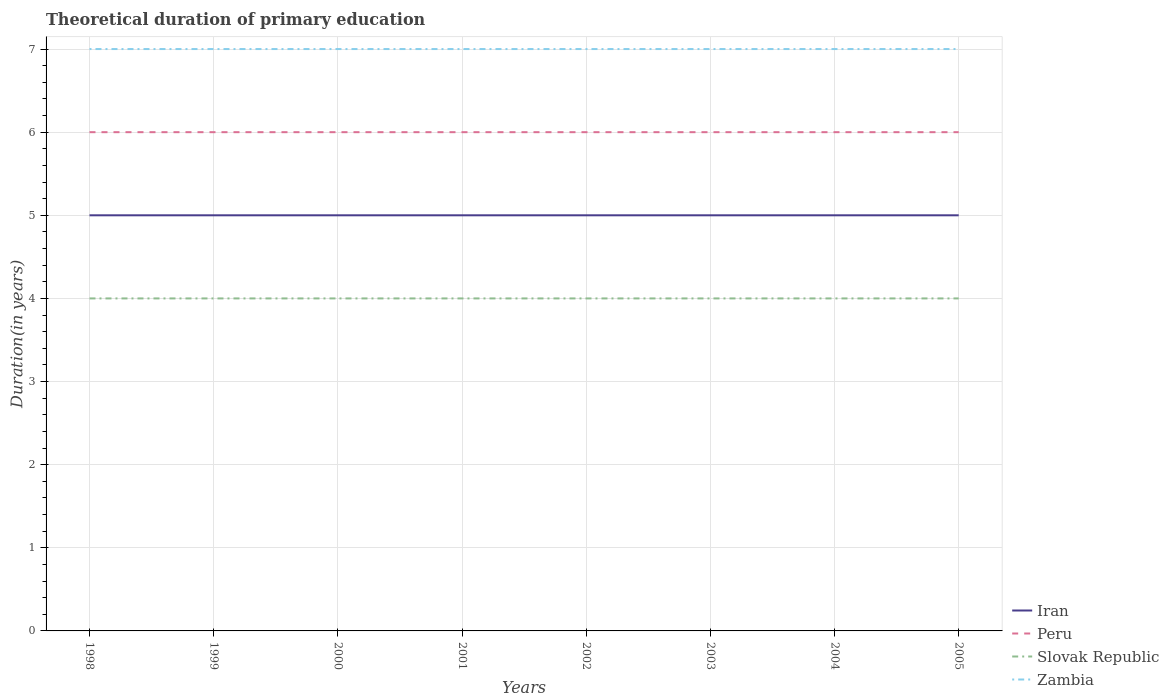Is the number of lines equal to the number of legend labels?
Give a very brief answer. Yes. Across all years, what is the maximum total theoretical duration of primary education in Zambia?
Your answer should be compact. 7. Is the total theoretical duration of primary education in Iran strictly greater than the total theoretical duration of primary education in Peru over the years?
Offer a very short reply. Yes. How many lines are there?
Provide a succinct answer. 4. How many years are there in the graph?
Keep it short and to the point. 8. Does the graph contain grids?
Make the answer very short. Yes. Where does the legend appear in the graph?
Your response must be concise. Bottom right. How many legend labels are there?
Keep it short and to the point. 4. How are the legend labels stacked?
Offer a terse response. Vertical. What is the title of the graph?
Give a very brief answer. Theoretical duration of primary education. What is the label or title of the Y-axis?
Keep it short and to the point. Duration(in years). What is the Duration(in years) of Peru in 1998?
Your answer should be very brief. 6. What is the Duration(in years) in Zambia in 1998?
Offer a very short reply. 7. What is the Duration(in years) in Peru in 1999?
Give a very brief answer. 6. What is the Duration(in years) of Iran in 2000?
Keep it short and to the point. 5. What is the Duration(in years) in Slovak Republic in 2001?
Your answer should be very brief. 4. What is the Duration(in years) in Iran in 2002?
Provide a short and direct response. 5. What is the Duration(in years) of Iran in 2003?
Offer a terse response. 5. What is the Duration(in years) of Peru in 2003?
Give a very brief answer. 6. What is the Duration(in years) of Zambia in 2003?
Make the answer very short. 7. What is the Duration(in years) of Iran in 2004?
Your answer should be compact. 5. What is the Duration(in years) in Iran in 2005?
Offer a very short reply. 5. Across all years, what is the maximum Duration(in years) of Iran?
Ensure brevity in your answer.  5. Across all years, what is the maximum Duration(in years) of Peru?
Ensure brevity in your answer.  6. Across all years, what is the maximum Duration(in years) in Slovak Republic?
Offer a terse response. 4. Across all years, what is the minimum Duration(in years) in Iran?
Your response must be concise. 5. Across all years, what is the minimum Duration(in years) of Peru?
Your answer should be very brief. 6. Across all years, what is the minimum Duration(in years) of Slovak Republic?
Your answer should be compact. 4. Across all years, what is the minimum Duration(in years) of Zambia?
Ensure brevity in your answer.  7. What is the total Duration(in years) in Iran in the graph?
Make the answer very short. 40. What is the total Duration(in years) of Peru in the graph?
Make the answer very short. 48. What is the difference between the Duration(in years) in Peru in 1998 and that in 1999?
Offer a very short reply. 0. What is the difference between the Duration(in years) of Iran in 1998 and that in 2000?
Offer a very short reply. 0. What is the difference between the Duration(in years) of Slovak Republic in 1998 and that in 2000?
Your answer should be compact. 0. What is the difference between the Duration(in years) in Zambia in 1998 and that in 2000?
Keep it short and to the point. 0. What is the difference between the Duration(in years) of Peru in 1998 and that in 2001?
Ensure brevity in your answer.  0. What is the difference between the Duration(in years) in Slovak Republic in 1998 and that in 2001?
Provide a short and direct response. 0. What is the difference between the Duration(in years) of Slovak Republic in 1998 and that in 2002?
Give a very brief answer. 0. What is the difference between the Duration(in years) of Iran in 1998 and that in 2003?
Make the answer very short. 0. What is the difference between the Duration(in years) in Iran in 1998 and that in 2004?
Your answer should be very brief. 0. What is the difference between the Duration(in years) of Iran in 1998 and that in 2005?
Ensure brevity in your answer.  0. What is the difference between the Duration(in years) of Peru in 1999 and that in 2000?
Keep it short and to the point. 0. What is the difference between the Duration(in years) of Zambia in 1999 and that in 2000?
Your answer should be very brief. 0. What is the difference between the Duration(in years) in Iran in 1999 and that in 2001?
Keep it short and to the point. 0. What is the difference between the Duration(in years) of Zambia in 1999 and that in 2001?
Your response must be concise. 0. What is the difference between the Duration(in years) of Iran in 1999 and that in 2002?
Provide a short and direct response. 0. What is the difference between the Duration(in years) in Slovak Republic in 1999 and that in 2002?
Your response must be concise. 0. What is the difference between the Duration(in years) of Zambia in 1999 and that in 2002?
Ensure brevity in your answer.  0. What is the difference between the Duration(in years) in Iran in 1999 and that in 2003?
Make the answer very short. 0. What is the difference between the Duration(in years) of Slovak Republic in 1999 and that in 2003?
Provide a succinct answer. 0. What is the difference between the Duration(in years) in Zambia in 1999 and that in 2004?
Provide a succinct answer. 0. What is the difference between the Duration(in years) of Iran in 1999 and that in 2005?
Offer a very short reply. 0. What is the difference between the Duration(in years) of Zambia in 1999 and that in 2005?
Provide a succinct answer. 0. What is the difference between the Duration(in years) of Iran in 2000 and that in 2001?
Offer a terse response. 0. What is the difference between the Duration(in years) in Slovak Republic in 2000 and that in 2001?
Keep it short and to the point. 0. What is the difference between the Duration(in years) in Zambia in 2000 and that in 2001?
Make the answer very short. 0. What is the difference between the Duration(in years) of Iran in 2000 and that in 2002?
Give a very brief answer. 0. What is the difference between the Duration(in years) of Peru in 2000 and that in 2002?
Your answer should be very brief. 0. What is the difference between the Duration(in years) in Slovak Republic in 2000 and that in 2002?
Offer a terse response. 0. What is the difference between the Duration(in years) of Zambia in 2000 and that in 2002?
Keep it short and to the point. 0. What is the difference between the Duration(in years) in Iran in 2000 and that in 2003?
Provide a short and direct response. 0. What is the difference between the Duration(in years) of Slovak Republic in 2000 and that in 2003?
Offer a very short reply. 0. What is the difference between the Duration(in years) in Zambia in 2000 and that in 2003?
Provide a succinct answer. 0. What is the difference between the Duration(in years) of Iran in 2000 and that in 2004?
Ensure brevity in your answer.  0. What is the difference between the Duration(in years) of Peru in 2000 and that in 2004?
Your answer should be compact. 0. What is the difference between the Duration(in years) in Iran in 2000 and that in 2005?
Provide a succinct answer. 0. What is the difference between the Duration(in years) of Peru in 2000 and that in 2005?
Keep it short and to the point. 0. What is the difference between the Duration(in years) in Iran in 2001 and that in 2002?
Ensure brevity in your answer.  0. What is the difference between the Duration(in years) of Slovak Republic in 2001 and that in 2002?
Offer a terse response. 0. What is the difference between the Duration(in years) of Zambia in 2001 and that in 2002?
Provide a short and direct response. 0. What is the difference between the Duration(in years) of Slovak Republic in 2001 and that in 2003?
Offer a terse response. 0. What is the difference between the Duration(in years) of Peru in 2001 and that in 2004?
Keep it short and to the point. 0. What is the difference between the Duration(in years) in Slovak Republic in 2001 and that in 2004?
Your answer should be very brief. 0. What is the difference between the Duration(in years) of Zambia in 2001 and that in 2004?
Offer a terse response. 0. What is the difference between the Duration(in years) in Iran in 2001 and that in 2005?
Ensure brevity in your answer.  0. What is the difference between the Duration(in years) in Zambia in 2001 and that in 2005?
Offer a terse response. 0. What is the difference between the Duration(in years) of Peru in 2002 and that in 2003?
Your response must be concise. 0. What is the difference between the Duration(in years) in Slovak Republic in 2002 and that in 2003?
Make the answer very short. 0. What is the difference between the Duration(in years) in Iran in 2002 and that in 2004?
Make the answer very short. 0. What is the difference between the Duration(in years) of Slovak Republic in 2002 and that in 2004?
Make the answer very short. 0. What is the difference between the Duration(in years) of Zambia in 2002 and that in 2004?
Provide a short and direct response. 0. What is the difference between the Duration(in years) of Iran in 2002 and that in 2005?
Ensure brevity in your answer.  0. What is the difference between the Duration(in years) in Peru in 2002 and that in 2005?
Make the answer very short. 0. What is the difference between the Duration(in years) of Iran in 2003 and that in 2004?
Keep it short and to the point. 0. What is the difference between the Duration(in years) in Peru in 2003 and that in 2004?
Your answer should be very brief. 0. What is the difference between the Duration(in years) in Slovak Republic in 2003 and that in 2004?
Provide a short and direct response. 0. What is the difference between the Duration(in years) in Iran in 2003 and that in 2005?
Give a very brief answer. 0. What is the difference between the Duration(in years) of Peru in 2003 and that in 2005?
Ensure brevity in your answer.  0. What is the difference between the Duration(in years) in Slovak Republic in 2003 and that in 2005?
Your answer should be very brief. 0. What is the difference between the Duration(in years) of Iran in 2004 and that in 2005?
Your response must be concise. 0. What is the difference between the Duration(in years) in Peru in 2004 and that in 2005?
Offer a terse response. 0. What is the difference between the Duration(in years) in Slovak Republic in 2004 and that in 2005?
Keep it short and to the point. 0. What is the difference between the Duration(in years) of Zambia in 2004 and that in 2005?
Your answer should be compact. 0. What is the difference between the Duration(in years) in Iran in 1998 and the Duration(in years) in Slovak Republic in 1999?
Your response must be concise. 1. What is the difference between the Duration(in years) of Iran in 1998 and the Duration(in years) of Zambia in 1999?
Give a very brief answer. -2. What is the difference between the Duration(in years) of Peru in 1998 and the Duration(in years) of Slovak Republic in 1999?
Give a very brief answer. 2. What is the difference between the Duration(in years) in Peru in 1998 and the Duration(in years) in Zambia in 1999?
Offer a terse response. -1. What is the difference between the Duration(in years) in Iran in 1998 and the Duration(in years) in Peru in 2000?
Provide a short and direct response. -1. What is the difference between the Duration(in years) of Iran in 1998 and the Duration(in years) of Slovak Republic in 2000?
Provide a succinct answer. 1. What is the difference between the Duration(in years) of Iran in 1998 and the Duration(in years) of Zambia in 2000?
Your answer should be compact. -2. What is the difference between the Duration(in years) in Peru in 1998 and the Duration(in years) in Slovak Republic in 2000?
Provide a short and direct response. 2. What is the difference between the Duration(in years) of Peru in 1998 and the Duration(in years) of Zambia in 2000?
Offer a very short reply. -1. What is the difference between the Duration(in years) in Iran in 1998 and the Duration(in years) in Peru in 2001?
Your answer should be compact. -1. What is the difference between the Duration(in years) in Iran in 1998 and the Duration(in years) in Zambia in 2001?
Provide a succinct answer. -2. What is the difference between the Duration(in years) of Peru in 1998 and the Duration(in years) of Slovak Republic in 2001?
Offer a very short reply. 2. What is the difference between the Duration(in years) in Slovak Republic in 1998 and the Duration(in years) in Zambia in 2001?
Provide a succinct answer. -3. What is the difference between the Duration(in years) of Iran in 1998 and the Duration(in years) of Slovak Republic in 2002?
Offer a very short reply. 1. What is the difference between the Duration(in years) in Iran in 1998 and the Duration(in years) in Zambia in 2002?
Your response must be concise. -2. What is the difference between the Duration(in years) of Peru in 1998 and the Duration(in years) of Slovak Republic in 2002?
Provide a succinct answer. 2. What is the difference between the Duration(in years) in Peru in 1998 and the Duration(in years) in Zambia in 2002?
Offer a terse response. -1. What is the difference between the Duration(in years) in Iran in 1998 and the Duration(in years) in Peru in 2003?
Provide a short and direct response. -1. What is the difference between the Duration(in years) of Iran in 1998 and the Duration(in years) of Slovak Republic in 2003?
Make the answer very short. 1. What is the difference between the Duration(in years) of Peru in 1998 and the Duration(in years) of Zambia in 2003?
Offer a very short reply. -1. What is the difference between the Duration(in years) in Slovak Republic in 1998 and the Duration(in years) in Zambia in 2003?
Give a very brief answer. -3. What is the difference between the Duration(in years) in Iran in 1998 and the Duration(in years) in Zambia in 2004?
Give a very brief answer. -2. What is the difference between the Duration(in years) in Peru in 1998 and the Duration(in years) in Slovak Republic in 2004?
Your answer should be compact. 2. What is the difference between the Duration(in years) of Peru in 1998 and the Duration(in years) of Zambia in 2004?
Ensure brevity in your answer.  -1. What is the difference between the Duration(in years) of Iran in 1998 and the Duration(in years) of Slovak Republic in 2005?
Your answer should be compact. 1. What is the difference between the Duration(in years) in Iran in 1998 and the Duration(in years) in Zambia in 2005?
Provide a short and direct response. -2. What is the difference between the Duration(in years) of Peru in 1998 and the Duration(in years) of Zambia in 2005?
Make the answer very short. -1. What is the difference between the Duration(in years) in Slovak Republic in 1998 and the Duration(in years) in Zambia in 2005?
Your response must be concise. -3. What is the difference between the Duration(in years) of Iran in 1999 and the Duration(in years) of Peru in 2000?
Your answer should be compact. -1. What is the difference between the Duration(in years) in Peru in 1999 and the Duration(in years) in Slovak Republic in 2000?
Ensure brevity in your answer.  2. What is the difference between the Duration(in years) in Peru in 1999 and the Duration(in years) in Zambia in 2000?
Offer a terse response. -1. What is the difference between the Duration(in years) in Iran in 1999 and the Duration(in years) in Peru in 2001?
Make the answer very short. -1. What is the difference between the Duration(in years) of Peru in 1999 and the Duration(in years) of Slovak Republic in 2001?
Your answer should be compact. 2. What is the difference between the Duration(in years) in Peru in 1999 and the Duration(in years) in Zambia in 2001?
Offer a terse response. -1. What is the difference between the Duration(in years) in Slovak Republic in 1999 and the Duration(in years) in Zambia in 2001?
Your response must be concise. -3. What is the difference between the Duration(in years) in Peru in 1999 and the Duration(in years) in Slovak Republic in 2002?
Give a very brief answer. 2. What is the difference between the Duration(in years) in Peru in 1999 and the Duration(in years) in Zambia in 2002?
Your answer should be very brief. -1. What is the difference between the Duration(in years) in Slovak Republic in 1999 and the Duration(in years) in Zambia in 2002?
Offer a very short reply. -3. What is the difference between the Duration(in years) in Iran in 1999 and the Duration(in years) in Peru in 2003?
Your answer should be compact. -1. What is the difference between the Duration(in years) of Iran in 1999 and the Duration(in years) of Slovak Republic in 2003?
Ensure brevity in your answer.  1. What is the difference between the Duration(in years) of Iran in 1999 and the Duration(in years) of Zambia in 2003?
Offer a very short reply. -2. What is the difference between the Duration(in years) of Iran in 1999 and the Duration(in years) of Slovak Republic in 2004?
Give a very brief answer. 1. What is the difference between the Duration(in years) in Iran in 1999 and the Duration(in years) in Slovak Republic in 2005?
Offer a terse response. 1. What is the difference between the Duration(in years) in Iran in 1999 and the Duration(in years) in Zambia in 2005?
Give a very brief answer. -2. What is the difference between the Duration(in years) of Peru in 1999 and the Duration(in years) of Slovak Republic in 2005?
Provide a succinct answer. 2. What is the difference between the Duration(in years) of Iran in 2000 and the Duration(in years) of Zambia in 2001?
Your answer should be compact. -2. What is the difference between the Duration(in years) in Iran in 2000 and the Duration(in years) in Peru in 2003?
Offer a very short reply. -1. What is the difference between the Duration(in years) in Iran in 2000 and the Duration(in years) in Slovak Republic in 2003?
Ensure brevity in your answer.  1. What is the difference between the Duration(in years) of Iran in 2000 and the Duration(in years) of Zambia in 2003?
Make the answer very short. -2. What is the difference between the Duration(in years) in Slovak Republic in 2000 and the Duration(in years) in Zambia in 2003?
Provide a succinct answer. -3. What is the difference between the Duration(in years) in Iran in 2000 and the Duration(in years) in Peru in 2004?
Your response must be concise. -1. What is the difference between the Duration(in years) in Peru in 2000 and the Duration(in years) in Zambia in 2004?
Provide a short and direct response. -1. What is the difference between the Duration(in years) in Iran in 2000 and the Duration(in years) in Peru in 2005?
Provide a succinct answer. -1. What is the difference between the Duration(in years) in Iran in 2000 and the Duration(in years) in Slovak Republic in 2005?
Offer a very short reply. 1. What is the difference between the Duration(in years) of Iran in 2000 and the Duration(in years) of Zambia in 2005?
Offer a very short reply. -2. What is the difference between the Duration(in years) in Peru in 2000 and the Duration(in years) in Slovak Republic in 2005?
Make the answer very short. 2. What is the difference between the Duration(in years) in Slovak Republic in 2000 and the Duration(in years) in Zambia in 2005?
Your answer should be compact. -3. What is the difference between the Duration(in years) in Iran in 2001 and the Duration(in years) in Slovak Republic in 2002?
Your answer should be very brief. 1. What is the difference between the Duration(in years) in Peru in 2001 and the Duration(in years) in Zambia in 2002?
Offer a very short reply. -1. What is the difference between the Duration(in years) in Iran in 2001 and the Duration(in years) in Slovak Republic in 2003?
Give a very brief answer. 1. What is the difference between the Duration(in years) of Iran in 2001 and the Duration(in years) of Peru in 2004?
Ensure brevity in your answer.  -1. What is the difference between the Duration(in years) in Iran in 2001 and the Duration(in years) in Zambia in 2004?
Keep it short and to the point. -2. What is the difference between the Duration(in years) in Slovak Republic in 2001 and the Duration(in years) in Zambia in 2004?
Offer a very short reply. -3. What is the difference between the Duration(in years) in Slovak Republic in 2001 and the Duration(in years) in Zambia in 2005?
Ensure brevity in your answer.  -3. What is the difference between the Duration(in years) of Iran in 2002 and the Duration(in years) of Peru in 2003?
Give a very brief answer. -1. What is the difference between the Duration(in years) in Iran in 2002 and the Duration(in years) in Zambia in 2003?
Give a very brief answer. -2. What is the difference between the Duration(in years) of Peru in 2002 and the Duration(in years) of Slovak Republic in 2003?
Provide a short and direct response. 2. What is the difference between the Duration(in years) of Peru in 2002 and the Duration(in years) of Zambia in 2003?
Provide a short and direct response. -1. What is the difference between the Duration(in years) in Iran in 2002 and the Duration(in years) in Slovak Republic in 2004?
Provide a short and direct response. 1. What is the difference between the Duration(in years) in Iran in 2002 and the Duration(in years) in Peru in 2005?
Your response must be concise. -1. What is the difference between the Duration(in years) in Iran in 2002 and the Duration(in years) in Zambia in 2005?
Keep it short and to the point. -2. What is the difference between the Duration(in years) of Peru in 2002 and the Duration(in years) of Slovak Republic in 2005?
Keep it short and to the point. 2. What is the difference between the Duration(in years) of Iran in 2003 and the Duration(in years) of Zambia in 2004?
Make the answer very short. -2. What is the difference between the Duration(in years) in Slovak Republic in 2003 and the Duration(in years) in Zambia in 2004?
Provide a short and direct response. -3. What is the difference between the Duration(in years) in Iran in 2003 and the Duration(in years) in Peru in 2005?
Make the answer very short. -1. What is the difference between the Duration(in years) in Iran in 2003 and the Duration(in years) in Zambia in 2005?
Make the answer very short. -2. What is the difference between the Duration(in years) of Peru in 2003 and the Duration(in years) of Zambia in 2005?
Make the answer very short. -1. What is the difference between the Duration(in years) of Peru in 2004 and the Duration(in years) of Zambia in 2005?
Provide a succinct answer. -1. What is the average Duration(in years) in Zambia per year?
Your response must be concise. 7. In the year 1998, what is the difference between the Duration(in years) of Iran and Duration(in years) of Slovak Republic?
Ensure brevity in your answer.  1. In the year 1998, what is the difference between the Duration(in years) in Iran and Duration(in years) in Zambia?
Make the answer very short. -2. In the year 1998, what is the difference between the Duration(in years) of Peru and Duration(in years) of Slovak Republic?
Your answer should be compact. 2. In the year 1998, what is the difference between the Duration(in years) of Slovak Republic and Duration(in years) of Zambia?
Ensure brevity in your answer.  -3. In the year 1999, what is the difference between the Duration(in years) in Slovak Republic and Duration(in years) in Zambia?
Give a very brief answer. -3. In the year 2000, what is the difference between the Duration(in years) of Iran and Duration(in years) of Slovak Republic?
Your answer should be very brief. 1. In the year 2000, what is the difference between the Duration(in years) in Peru and Duration(in years) in Slovak Republic?
Give a very brief answer. 2. In the year 2000, what is the difference between the Duration(in years) of Peru and Duration(in years) of Zambia?
Your answer should be compact. -1. In the year 2000, what is the difference between the Duration(in years) of Slovak Republic and Duration(in years) of Zambia?
Offer a terse response. -3. In the year 2001, what is the difference between the Duration(in years) of Iran and Duration(in years) of Peru?
Give a very brief answer. -1. In the year 2001, what is the difference between the Duration(in years) of Iran and Duration(in years) of Slovak Republic?
Your answer should be compact. 1. In the year 2001, what is the difference between the Duration(in years) of Peru and Duration(in years) of Zambia?
Your response must be concise. -1. In the year 2001, what is the difference between the Duration(in years) of Slovak Republic and Duration(in years) of Zambia?
Provide a short and direct response. -3. In the year 2002, what is the difference between the Duration(in years) in Iran and Duration(in years) in Slovak Republic?
Provide a short and direct response. 1. In the year 2003, what is the difference between the Duration(in years) in Iran and Duration(in years) in Slovak Republic?
Provide a succinct answer. 1. In the year 2003, what is the difference between the Duration(in years) in Iran and Duration(in years) in Zambia?
Make the answer very short. -2. In the year 2003, what is the difference between the Duration(in years) in Peru and Duration(in years) in Slovak Republic?
Keep it short and to the point. 2. In the year 2003, what is the difference between the Duration(in years) of Peru and Duration(in years) of Zambia?
Provide a short and direct response. -1. In the year 2003, what is the difference between the Duration(in years) in Slovak Republic and Duration(in years) in Zambia?
Offer a very short reply. -3. In the year 2004, what is the difference between the Duration(in years) of Iran and Duration(in years) of Peru?
Provide a short and direct response. -1. In the year 2005, what is the difference between the Duration(in years) in Peru and Duration(in years) in Slovak Republic?
Provide a short and direct response. 2. In the year 2005, what is the difference between the Duration(in years) in Slovak Republic and Duration(in years) in Zambia?
Your answer should be compact. -3. What is the ratio of the Duration(in years) of Peru in 1998 to that in 1999?
Offer a very short reply. 1. What is the ratio of the Duration(in years) in Zambia in 1998 to that in 1999?
Keep it short and to the point. 1. What is the ratio of the Duration(in years) in Iran in 1998 to that in 2000?
Provide a succinct answer. 1. What is the ratio of the Duration(in years) in Slovak Republic in 1998 to that in 2000?
Offer a terse response. 1. What is the ratio of the Duration(in years) in Zambia in 1998 to that in 2000?
Your answer should be very brief. 1. What is the ratio of the Duration(in years) of Iran in 1998 to that in 2001?
Your response must be concise. 1. What is the ratio of the Duration(in years) in Zambia in 1998 to that in 2001?
Provide a short and direct response. 1. What is the ratio of the Duration(in years) of Iran in 1998 to that in 2002?
Your answer should be very brief. 1. What is the ratio of the Duration(in years) of Peru in 1998 to that in 2003?
Your answer should be very brief. 1. What is the ratio of the Duration(in years) in Slovak Republic in 1998 to that in 2003?
Provide a succinct answer. 1. What is the ratio of the Duration(in years) in Zambia in 1998 to that in 2003?
Give a very brief answer. 1. What is the ratio of the Duration(in years) in Peru in 1998 to that in 2005?
Provide a short and direct response. 1. What is the ratio of the Duration(in years) of Zambia in 1998 to that in 2005?
Your response must be concise. 1. What is the ratio of the Duration(in years) of Iran in 1999 to that in 2000?
Make the answer very short. 1. What is the ratio of the Duration(in years) in Peru in 1999 to that in 2000?
Your answer should be compact. 1. What is the ratio of the Duration(in years) in Slovak Republic in 1999 to that in 2000?
Offer a terse response. 1. What is the ratio of the Duration(in years) of Peru in 1999 to that in 2001?
Keep it short and to the point. 1. What is the ratio of the Duration(in years) of Iran in 1999 to that in 2002?
Keep it short and to the point. 1. What is the ratio of the Duration(in years) in Peru in 1999 to that in 2002?
Your response must be concise. 1. What is the ratio of the Duration(in years) in Slovak Republic in 1999 to that in 2002?
Your answer should be compact. 1. What is the ratio of the Duration(in years) of Peru in 1999 to that in 2003?
Make the answer very short. 1. What is the ratio of the Duration(in years) in Peru in 1999 to that in 2004?
Offer a very short reply. 1. What is the ratio of the Duration(in years) in Slovak Republic in 1999 to that in 2004?
Provide a succinct answer. 1. What is the ratio of the Duration(in years) of Slovak Republic in 1999 to that in 2005?
Give a very brief answer. 1. What is the ratio of the Duration(in years) in Zambia in 1999 to that in 2005?
Your response must be concise. 1. What is the ratio of the Duration(in years) of Iran in 2000 to that in 2001?
Give a very brief answer. 1. What is the ratio of the Duration(in years) of Peru in 2000 to that in 2001?
Offer a terse response. 1. What is the ratio of the Duration(in years) of Slovak Republic in 2000 to that in 2001?
Ensure brevity in your answer.  1. What is the ratio of the Duration(in years) of Zambia in 2000 to that in 2001?
Give a very brief answer. 1. What is the ratio of the Duration(in years) of Peru in 2000 to that in 2003?
Your answer should be compact. 1. What is the ratio of the Duration(in years) in Slovak Republic in 2000 to that in 2003?
Your response must be concise. 1. What is the ratio of the Duration(in years) in Zambia in 2000 to that in 2003?
Ensure brevity in your answer.  1. What is the ratio of the Duration(in years) in Peru in 2000 to that in 2004?
Offer a very short reply. 1. What is the ratio of the Duration(in years) of Slovak Republic in 2000 to that in 2005?
Offer a terse response. 1. What is the ratio of the Duration(in years) in Iran in 2001 to that in 2002?
Ensure brevity in your answer.  1. What is the ratio of the Duration(in years) of Slovak Republic in 2001 to that in 2002?
Make the answer very short. 1. What is the ratio of the Duration(in years) in Zambia in 2001 to that in 2002?
Provide a succinct answer. 1. What is the ratio of the Duration(in years) in Iran in 2001 to that in 2003?
Your response must be concise. 1. What is the ratio of the Duration(in years) of Peru in 2001 to that in 2005?
Your response must be concise. 1. What is the ratio of the Duration(in years) of Zambia in 2001 to that in 2005?
Offer a very short reply. 1. What is the ratio of the Duration(in years) of Slovak Republic in 2002 to that in 2004?
Give a very brief answer. 1. What is the ratio of the Duration(in years) in Iran in 2002 to that in 2005?
Make the answer very short. 1. What is the ratio of the Duration(in years) in Peru in 2002 to that in 2005?
Your answer should be very brief. 1. What is the ratio of the Duration(in years) of Zambia in 2002 to that in 2005?
Make the answer very short. 1. What is the ratio of the Duration(in years) in Iran in 2003 to that in 2005?
Provide a short and direct response. 1. What is the ratio of the Duration(in years) of Peru in 2003 to that in 2005?
Ensure brevity in your answer.  1. What is the ratio of the Duration(in years) in Zambia in 2003 to that in 2005?
Offer a very short reply. 1. What is the ratio of the Duration(in years) of Slovak Republic in 2004 to that in 2005?
Offer a very short reply. 1. What is the ratio of the Duration(in years) of Zambia in 2004 to that in 2005?
Make the answer very short. 1. What is the difference between the highest and the second highest Duration(in years) of Iran?
Ensure brevity in your answer.  0. What is the difference between the highest and the second highest Duration(in years) in Peru?
Provide a short and direct response. 0. What is the difference between the highest and the second highest Duration(in years) in Zambia?
Make the answer very short. 0. What is the difference between the highest and the lowest Duration(in years) in Peru?
Your answer should be very brief. 0. What is the difference between the highest and the lowest Duration(in years) in Slovak Republic?
Keep it short and to the point. 0. What is the difference between the highest and the lowest Duration(in years) of Zambia?
Offer a terse response. 0. 